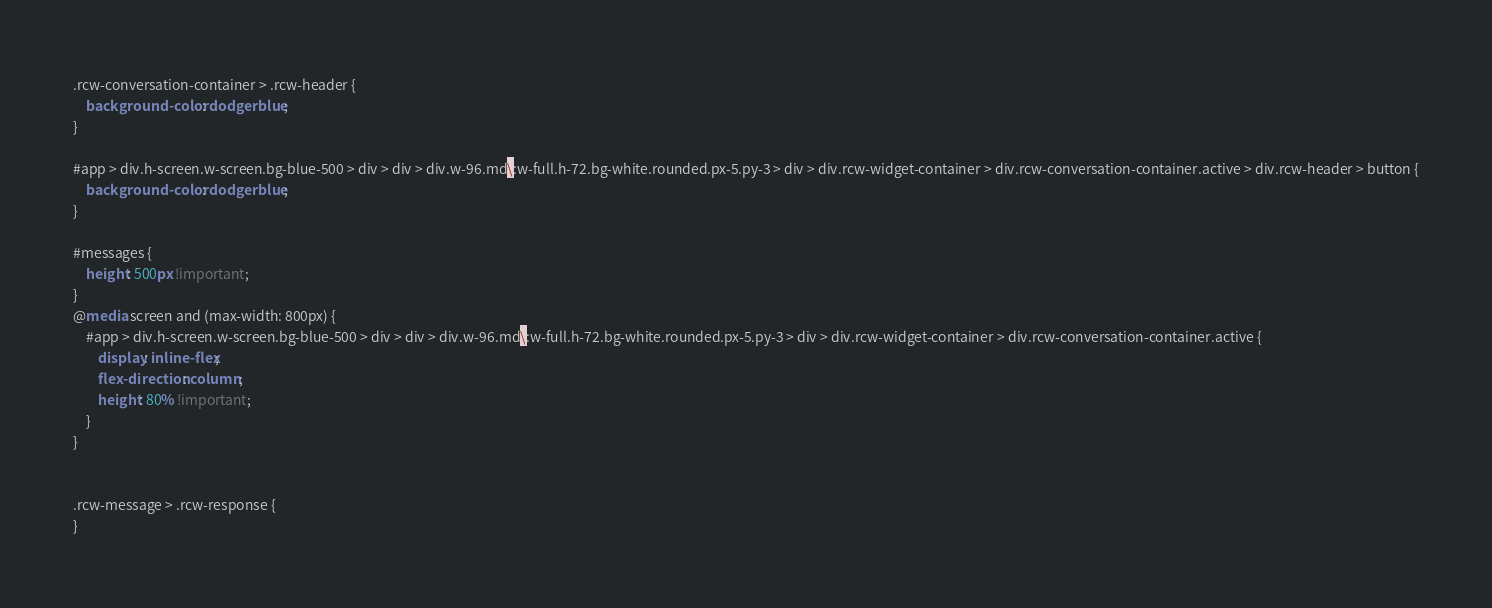<code> <loc_0><loc_0><loc_500><loc_500><_CSS_>.rcw-conversation-container > .rcw-header {
    background-color: dodgerblue;
}

#app > div.h-screen.w-screen.bg-blue-500 > div > div > div.w-96.md\:w-full.h-72.bg-white.rounded.px-5.py-3 > div > div.rcw-widget-container > div.rcw-conversation-container.active > div.rcw-header > button {
    background-color: dodgerblue;
}

#messages {
    height: 500px !important;
}
@media screen and (max-width: 800px) {
    #app > div.h-screen.w-screen.bg-blue-500 > div > div > div.w-96.md\:w-full.h-72.bg-white.rounded.px-5.py-3 > div > div.rcw-widget-container > div.rcw-conversation-container.active {
        display: inline-flex;
        flex-direction: column;
        height: 80% !important;
    }
}


.rcw-message > .rcw-response {
}
</code> 